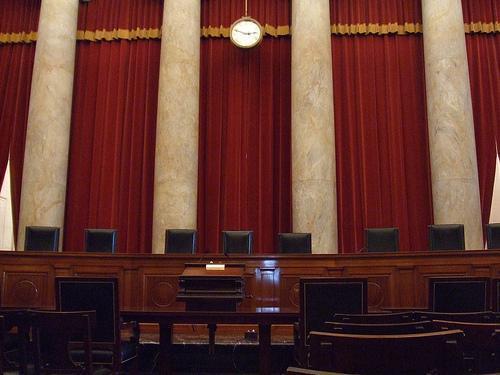How many chairs are in the front?
Give a very brief answer. 8. 